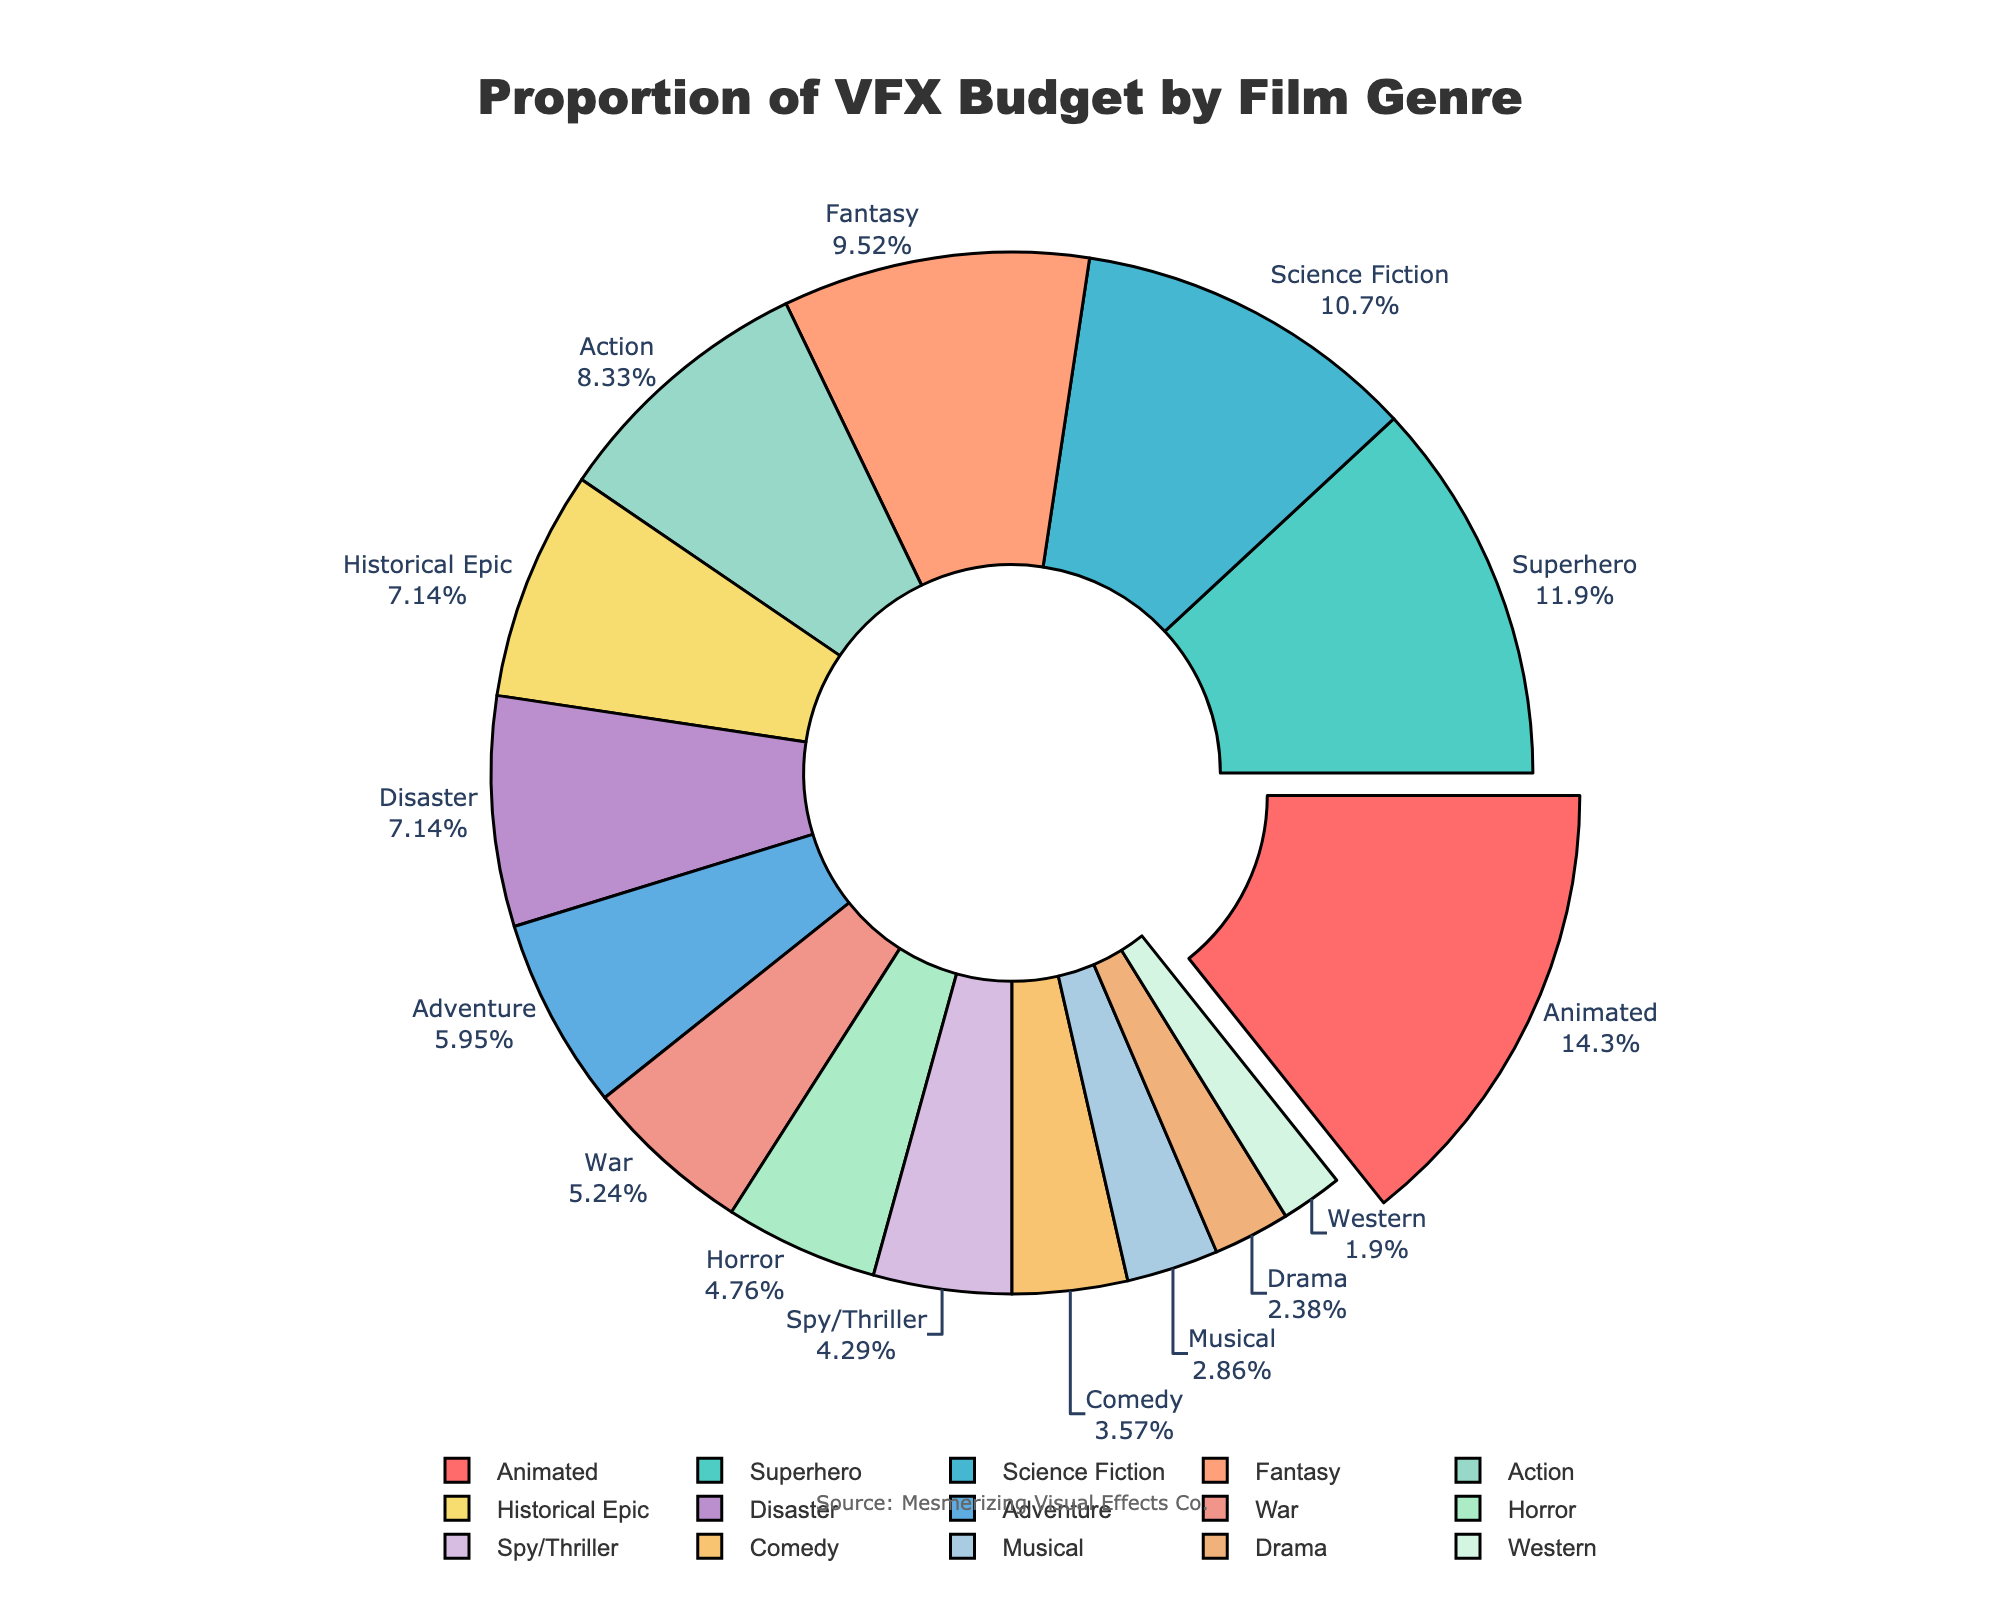Which genre has the highest proportion of VFX budget? According to the sorted pie chart, the 'Animated' genre has the highest proportion of VFX budget.
Answer: Animated Which genre has the lowest proportion of VFX budget? The genre with the lowest proportion of VFX budget is 'Western' as indicated in the chart.
Answer: Western What is the combined proportion of VFX budgets for 'Action' and 'Science Fiction' genres? Adding the proportions of VFX budgets for 'Action' (35) and 'Science Fiction' (45) gives a combined proportion of 80.
Answer: 80 How does the VFX budget of 'Fantasy' compare to 'Historical Epic'? The pie chart shows the proportion of VFX budgets for 'Fantasy' is 40, while for 'Historical Epic' it is 30. So, 'Fantasy' has a higher VFX budget proportion compared to 'Historical Epic'.
Answer: Fantasy has a higher proportion Which genres have a VFX budget proportion greater than 20 but less than 40? From the chart, the genres with VFX budget proportions greater than 20 but less than 40 are 'Action' (35), 'Fantasy' (40), 'Historical Epic' (30), and 'Disaster' (30).
Answer: Action, Fantasy, Historical Epic, Disaster What is the average VFX budget proportion for 'Spy/Thriller', 'Musical', and 'War' genres? To find the average, sum the proportions for 'Spy/Thriller' (18), 'Musical' (12), and 'War' (22), and then divide by the number of genres: (18 + 12 + 22) / 3 = 52 / 3 = 17.33.
Answer: 17.33 Compare the VFX budget proportions between 'Drama' and 'Comedy'. Which one is higher, and by how much? 'Comedy' has a VFX budget proportion of 15, while 'Drama' has 10. So, 'Comedy' has a higher proportion by (15 - 10) = 5.
Answer: Comedy, by 5 Which genre is depicted using the red color? The 'Action' genre is depicted using the red color in the chart.
Answer: Action What is the median VFX budget proportion among all listed genres? Sorting the proportions: 8, 10, 12, 15, 18, 20, 22, 25, 30, 30, 35, 40, 45, 50, 60. The middle value (median) is 25, which corresponds to the 'Adventure' genre.
Answer: 25 Which genres have a VFX budget proportion between 'Horror' and 'Disaster'? 'Horror' has a VFX budget of 20, and 'Disaster' has 30. The genres between 20 and 30 are 'Spy/Thriller' (18), 'War' (22), and 'Adventure' (25).
Answer: Spy/Thriller, War, Adventure 